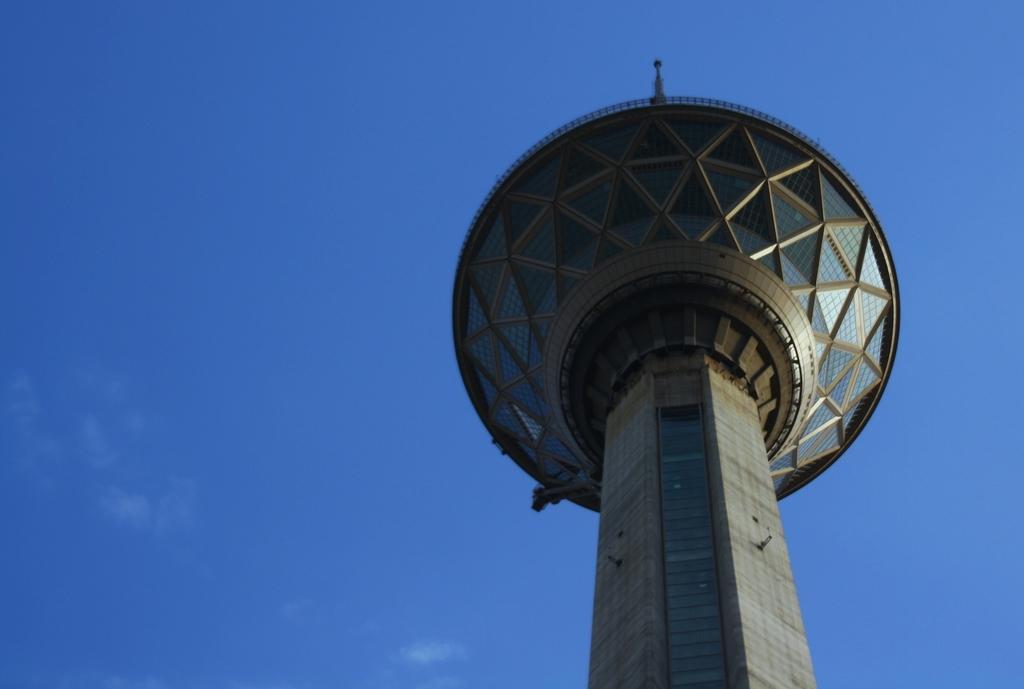How would you summarize this image in a sentence or two? In this image we can see a tower. In the background there is sky. 